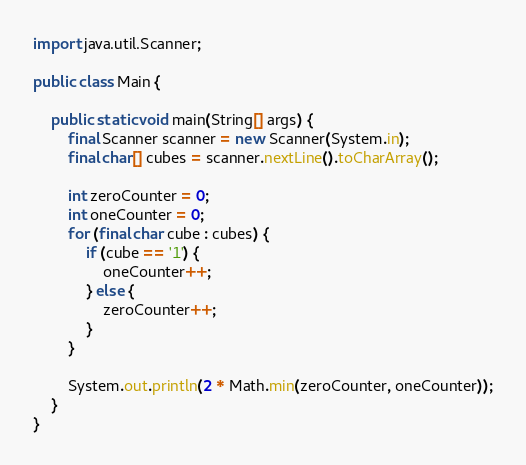<code> <loc_0><loc_0><loc_500><loc_500><_Java_>
import java.util.Scanner;

public class Main {

    public static void main(String[] args) {
        final Scanner scanner = new Scanner(System.in);
        final char[] cubes = scanner.nextLine().toCharArray();

        int zeroCounter = 0;
        int oneCounter = 0;
        for (final char cube : cubes) {
            if (cube == '1') {
                oneCounter++;
            } else {
                zeroCounter++;
            }
        }

        System.out.println(2 * Math.min(zeroCounter, oneCounter));
    }
}
</code> 